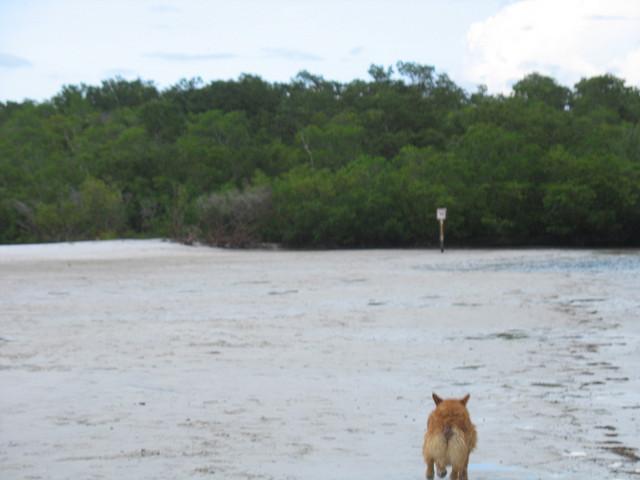Is the dog flying?
Short answer required. No. Will the dog swim?
Be succinct. No. How many dogs?
Be succinct. 1. Where is the dog?
Give a very brief answer. Beach. What plant is shown?
Keep it brief. Trees. What color is the dog?
Be succinct. Brown. Does the animal have a tail?
Quick response, please. Yes. What animal is standing alone?
Concise answer only. Dog. 